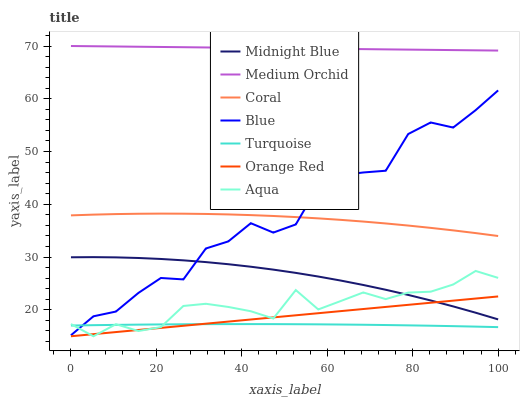Does Turquoise have the minimum area under the curve?
Answer yes or no. Yes. Does Medium Orchid have the maximum area under the curve?
Answer yes or no. Yes. Does Midnight Blue have the minimum area under the curve?
Answer yes or no. No. Does Midnight Blue have the maximum area under the curve?
Answer yes or no. No. Is Orange Red the smoothest?
Answer yes or no. Yes. Is Blue the roughest?
Answer yes or no. Yes. Is Turquoise the smoothest?
Answer yes or no. No. Is Turquoise the roughest?
Answer yes or no. No. Does Aqua have the lowest value?
Answer yes or no. Yes. Does Turquoise have the lowest value?
Answer yes or no. No. Does Medium Orchid have the highest value?
Answer yes or no. Yes. Does Midnight Blue have the highest value?
Answer yes or no. No. Is Orange Red less than Blue?
Answer yes or no. Yes. Is Medium Orchid greater than Blue?
Answer yes or no. Yes. Does Aqua intersect Orange Red?
Answer yes or no. Yes. Is Aqua less than Orange Red?
Answer yes or no. No. Is Aqua greater than Orange Red?
Answer yes or no. No. Does Orange Red intersect Blue?
Answer yes or no. No. 